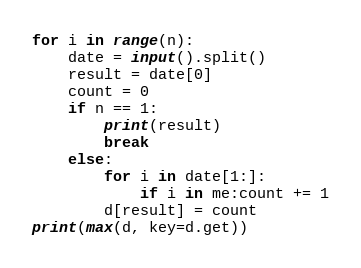Convert code to text. <code><loc_0><loc_0><loc_500><loc_500><_Python_>for i in range(n):
    date = input().split()
    result = date[0]
    count = 0
    if n == 1:
        print(result)
        break
    else:
        for i in date[1:]:
            if i in me:count += 1
        d[result] = count
print(max(d, key=d.get))
</code> 